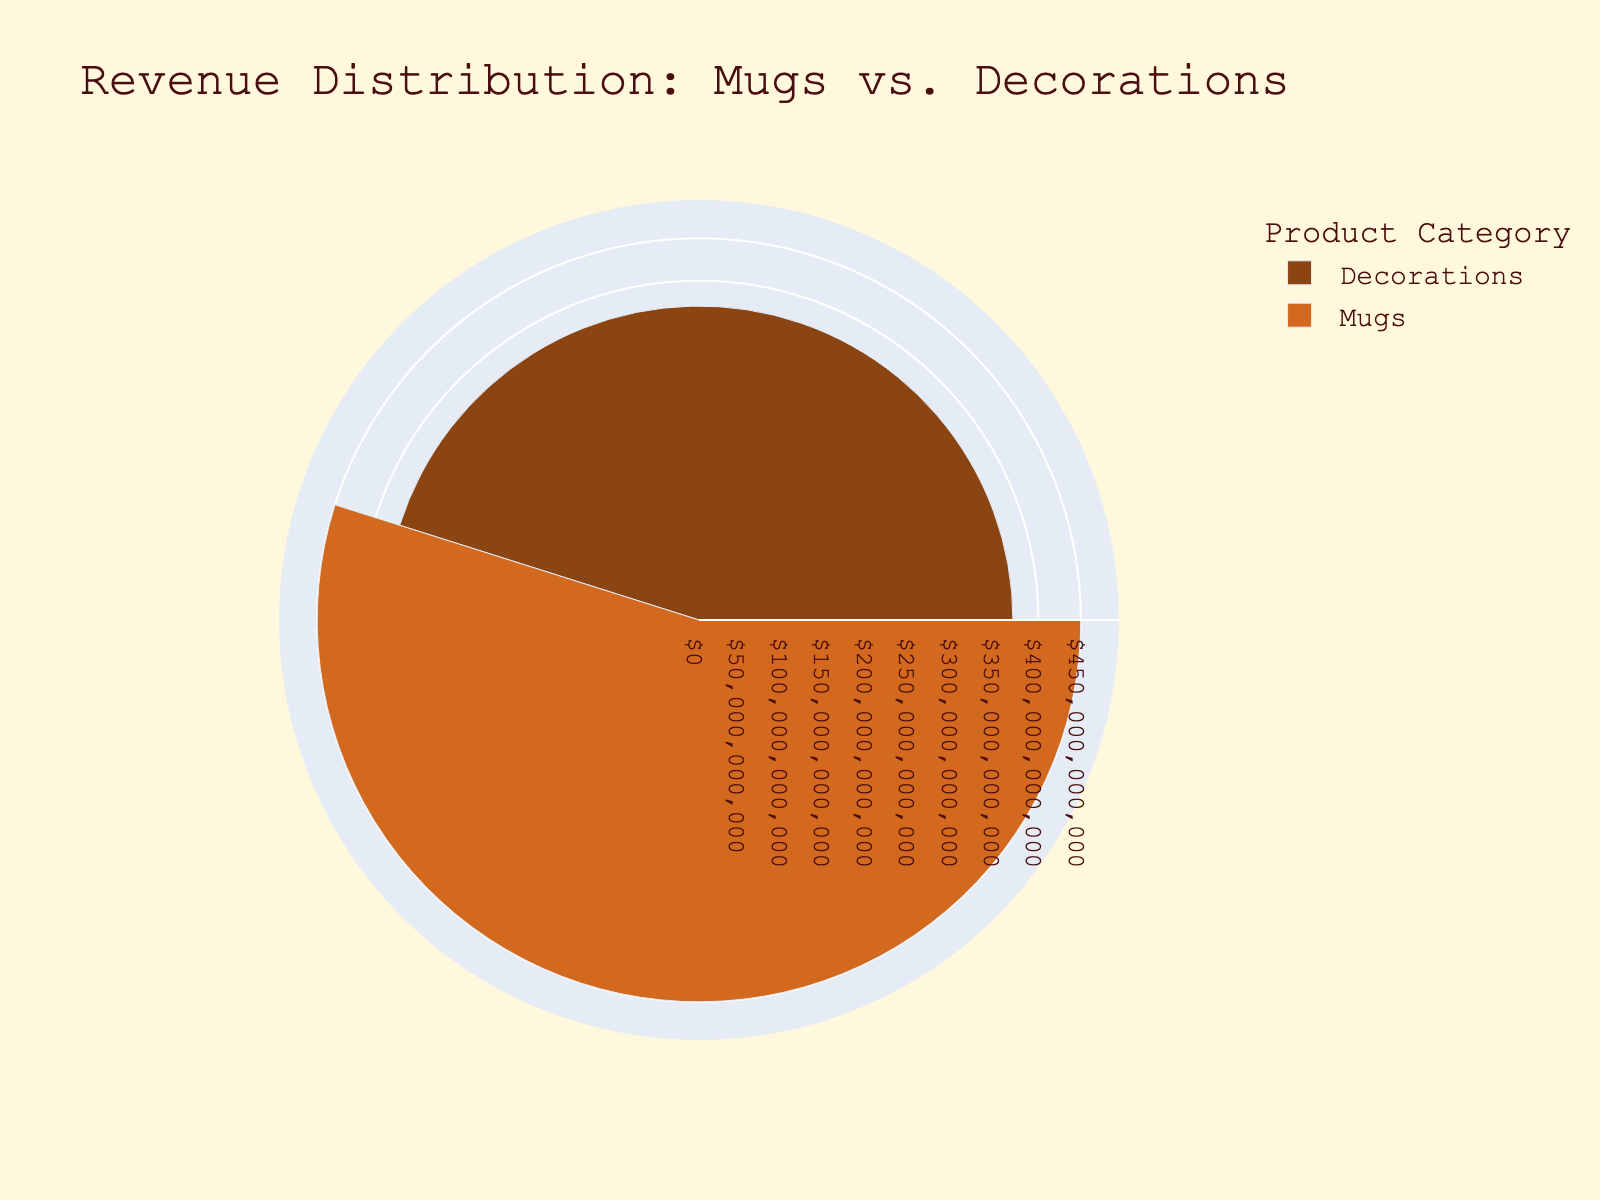What are the two categories shown in the title? The title of the chart is "Revenue Distribution: Mugs vs. Decorations," which indicates the two categories.
Answer: Mugs and Decorations What is the total revenue generated by Mugs? Each category's revenue is summed together from the figure. Adding the revenues of Classic Coffee Mug ($4500), Custom Name Mug ($3200), and Holiday Themed Mug ($2800) gives a total of $10500.
Answer: $10500 Which category has the highest revenue? By comparing the total revenues of both categories, Decorations have $8200, while Mugs have $10500. Therefore, Mugs have the highest revenue.
Answer: Mugs How many categories have a revenue greater than $8000? By evaluating the total revenue of each category, Mugs have $10500 and Decorations have $8200, both of which are greater than $8000.
Answer: Two What is the average revenue per product in the Decorations category? The total revenue for Decorations is $8200. There are three products in this category. Average revenue per product is calculated as $8200 / 3 = $2733.33.
Answer: $2733.33 In terms of revenue, which is the least successful product in the Decorations category? The figure shows the revenues of each product, wherein the Hanging Mobiles have the lowest revenue of $1900 in the Decorations category.
Answer: Hanging Mobiles Which category has the largest segment in the rose chart? By visual inspection, the segment representing Mugs is larger than that of Decorations, corresponding to higher revenue.
Answer: Mugs What is the difference in revenue between Mugs and Decorations? The total revenue for Mugs is $10500, and for Decorations, it is $8200. The difference is $10500 - $8200 = $2300.
Answer: $2300 What percentage of the total revenue is from Decorations? The revenue from Decorations is $8200 and the total revenue is $18700 ($10500 from Mugs + $8200 from Decorations). The percentage is ($8200 / $18700) * 100% = 43.85%.
Answer: 43.85% If another product in the Mugs category was added with a revenue of $1500, what would be the new total revenue for the Mugs category? The current revenue for Mugs is $10500. Adding another product with $1500 raises the total to $10500 + $1500 = $12000.
Answer: $12000 